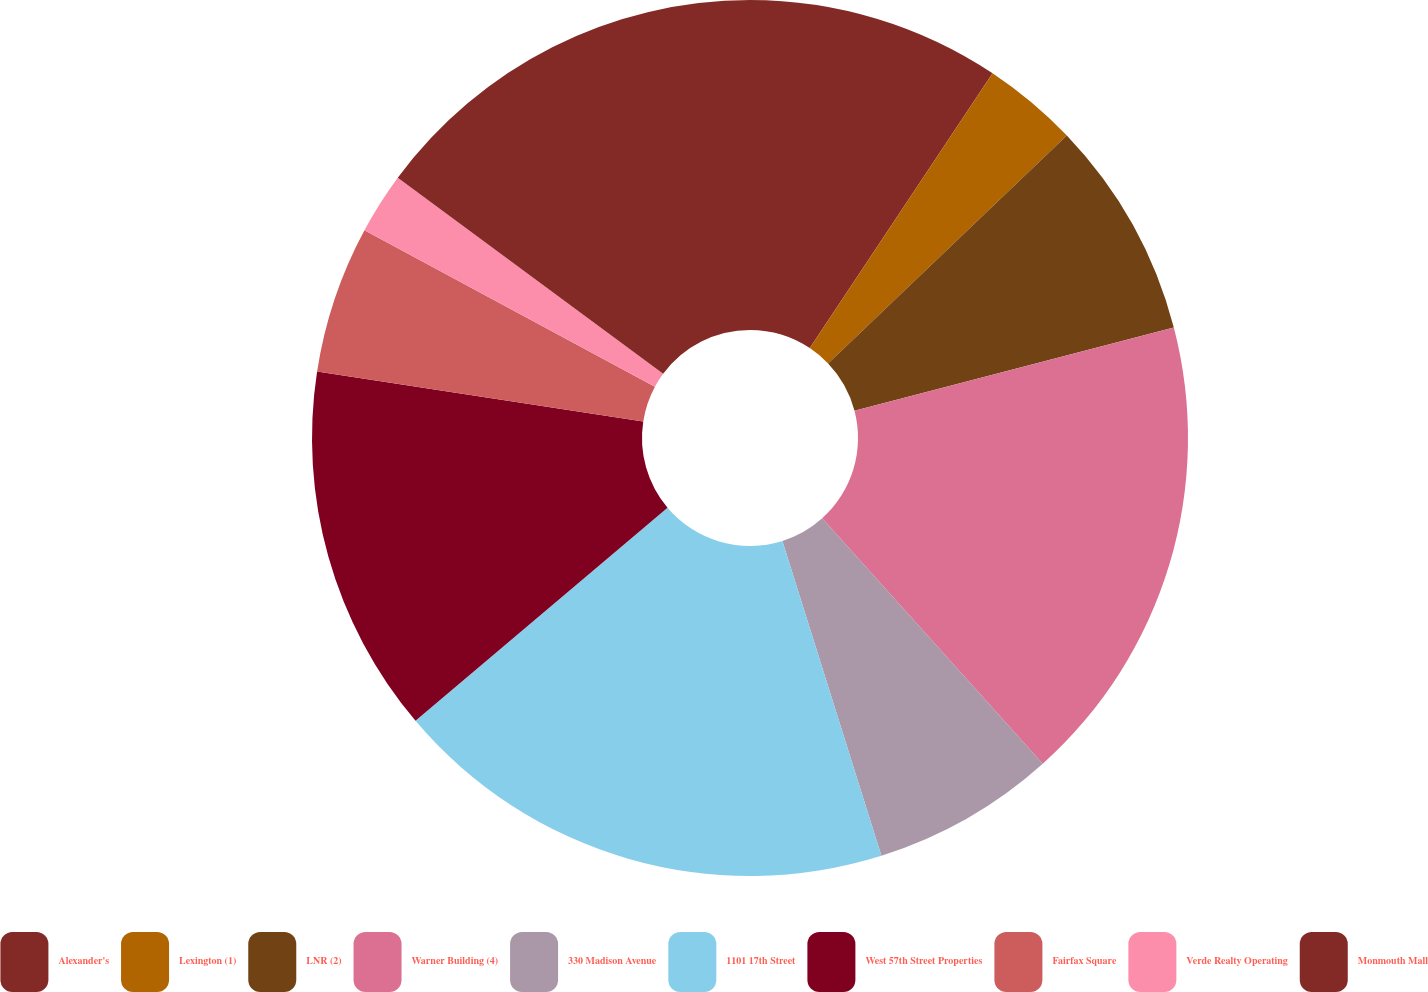Convert chart to OTSL. <chart><loc_0><loc_0><loc_500><loc_500><pie_chart><fcel>Alexander's<fcel>Lexington (1)<fcel>LNR (2)<fcel>Warner Building (4)<fcel>330 Madison Avenue<fcel>1101 17th Street<fcel>West 57th Street Properties<fcel>Fairfax Square<fcel>Verde Realty Operating<fcel>Monmouth Mall<nl><fcel>9.34%<fcel>3.53%<fcel>8.07%<fcel>17.41%<fcel>6.8%<fcel>18.68%<fcel>13.6%<fcel>5.44%<fcel>2.26%<fcel>14.87%<nl></chart> 